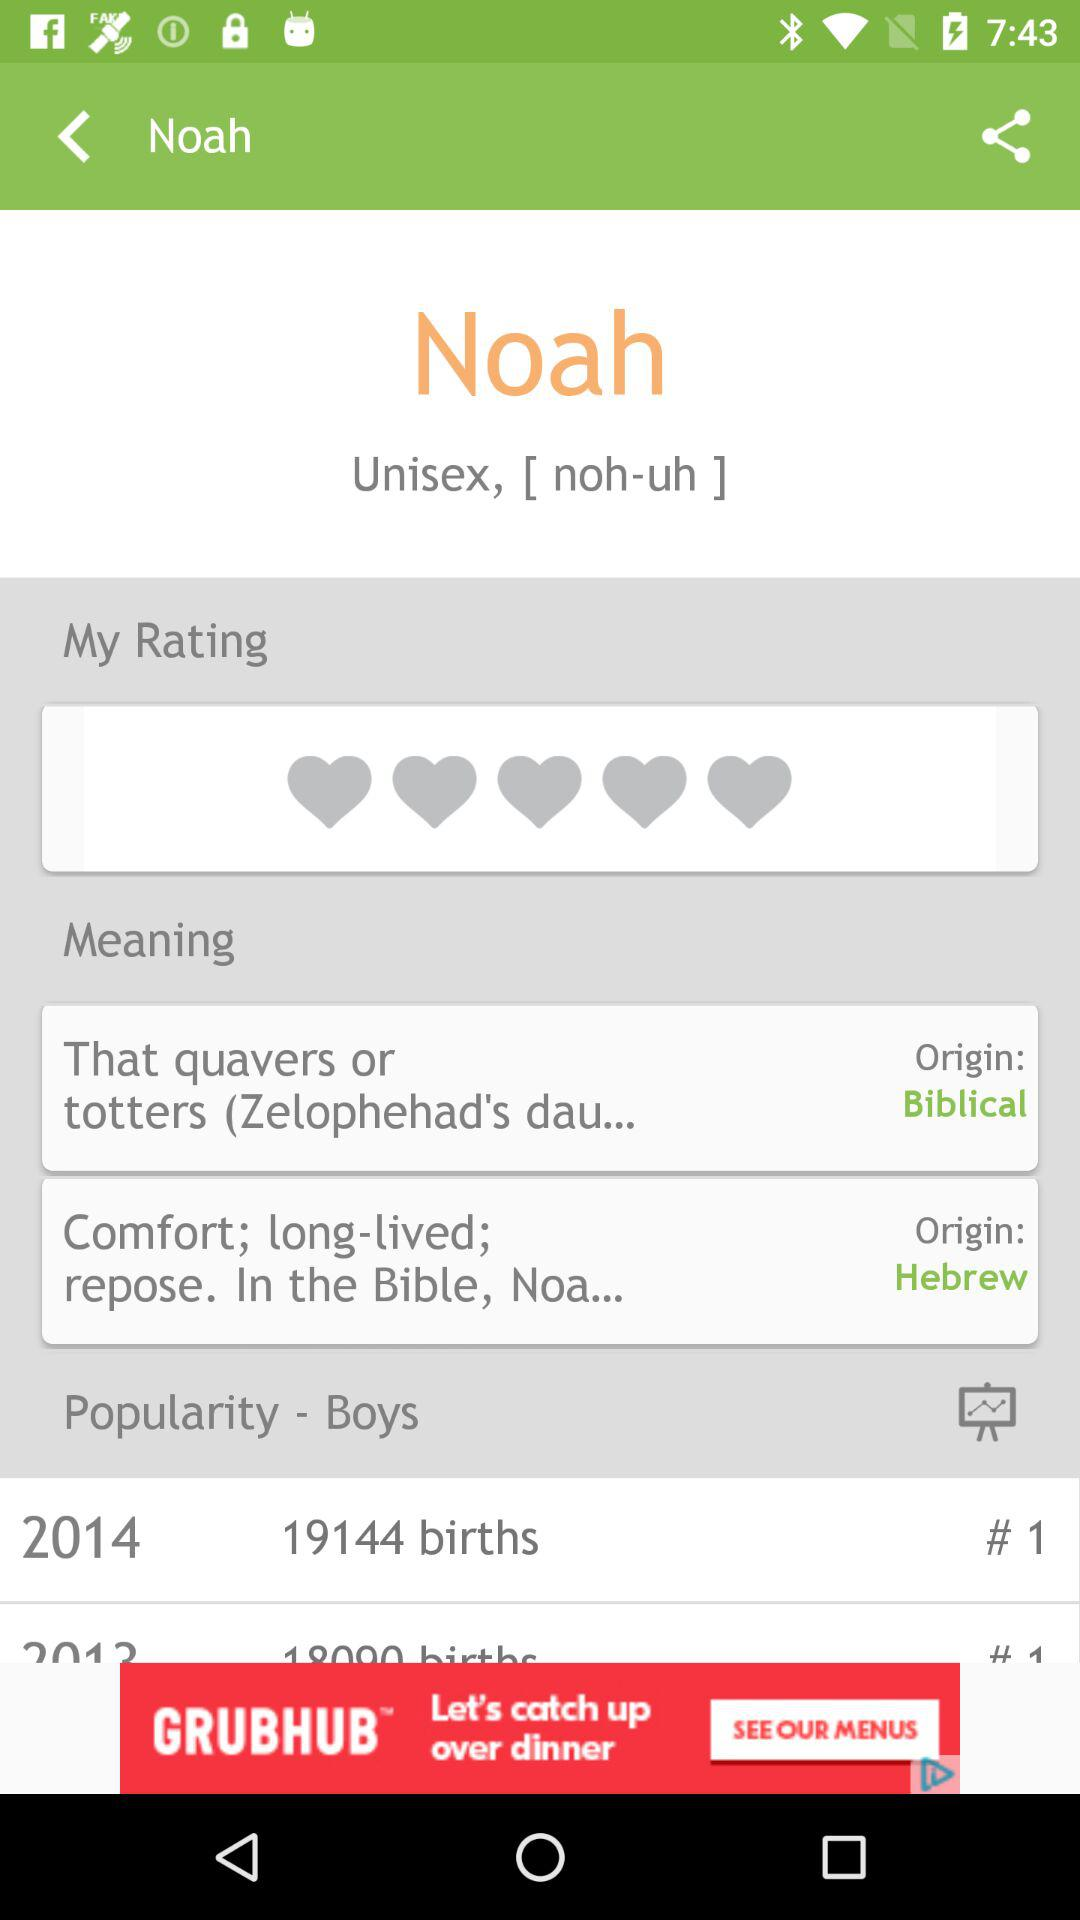What type of name is Noah? Noah is a unisex name. 